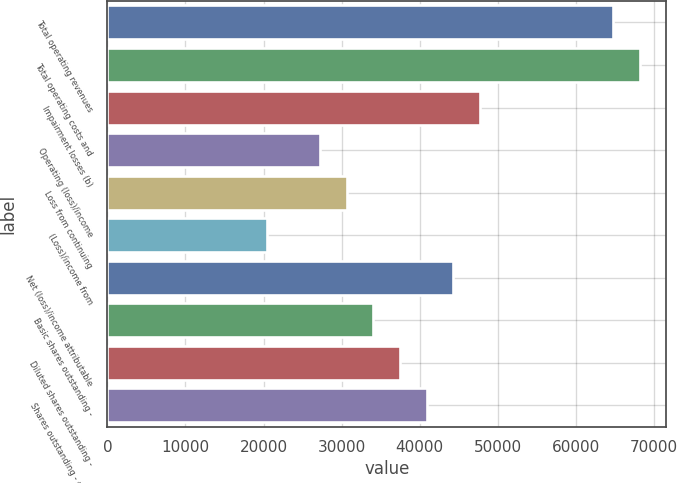Convert chart to OTSL. <chart><loc_0><loc_0><loc_500><loc_500><bar_chart><fcel>Total operating revenues<fcel>Total operating costs and<fcel>Impairment losses (b)<fcel>Operating (loss)/income<fcel>Loss from continuing<fcel>(Loss)/income from<fcel>Net (loss)/income attributable<fcel>Basic shares outstanding -<fcel>Diluted shares outstanding -<fcel>Shares outstanding - end of<nl><fcel>64753.5<fcel>68161.6<fcel>47713.2<fcel>27264.8<fcel>30672.9<fcel>20448.7<fcel>44305.1<fcel>34081<fcel>37489<fcel>40897.1<nl></chart> 